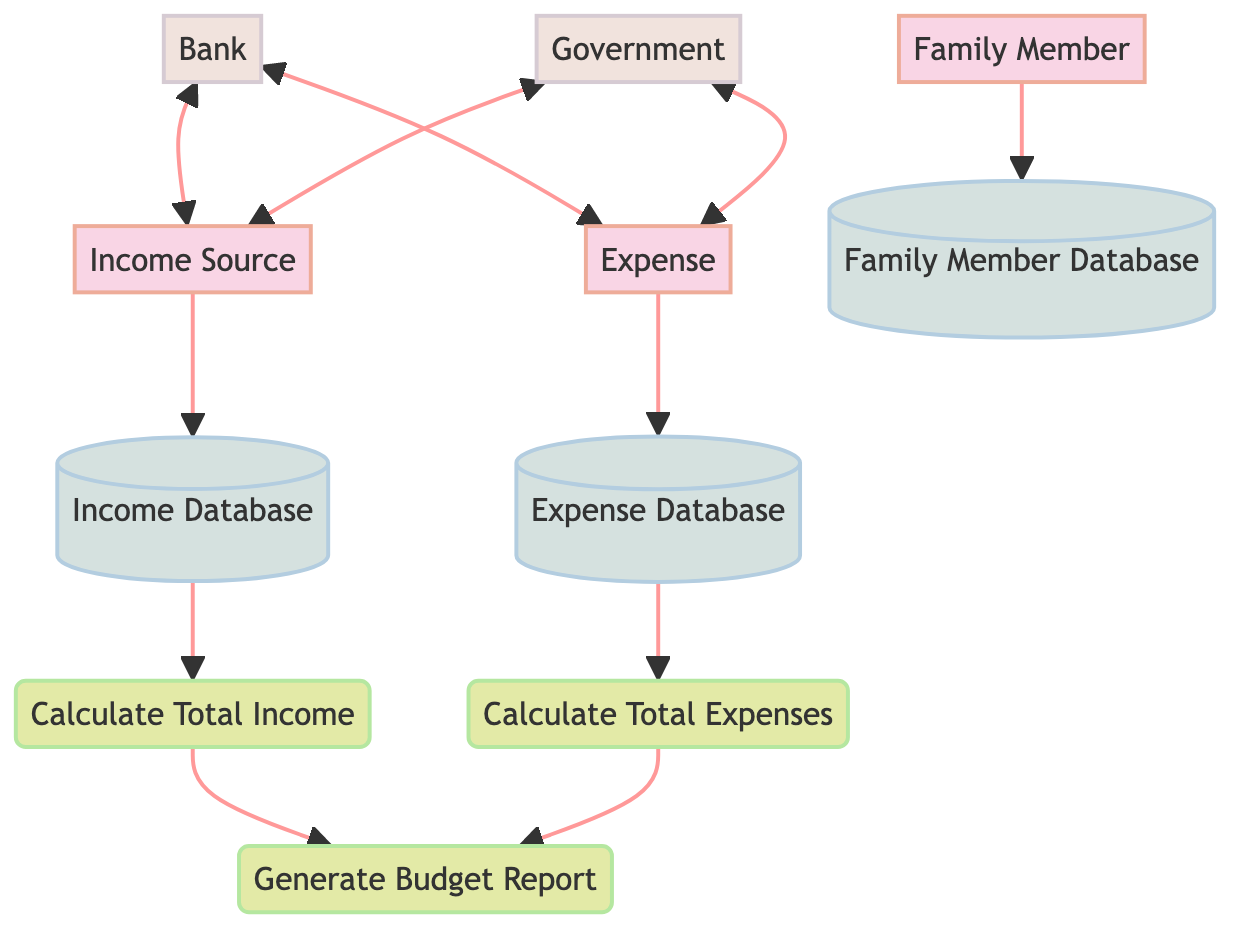What are the entities in the diagram? The diagram includes three entities: Family Member, Income Source, and Expense. Each has specific attributes associated with it, which define their characteristics.
Answer: Family Member, Income Source, Expense How many processes are in the diagram? The diagram contains three processes: Calculate Total Income, Calculate Total Expenses, and Generate Budget Report. Each process performs a specific function related to the family's budget.
Answer: 3 What is the output of the Calculate Total Income process? The process of Calculate Total Income takes Income Source as input and produces Total Income as output, which represents the sum of all income sources.
Answer: Total Income What is the purpose of the Expense Database? The Expense Database stores details regarding family expenditures, including Expense Type, Amount, and Due Date. It acts as a repository for tracking expenses systematically.
Answer: Stores details of all expenses Which external entity is involved in income and expenses? Both the Bank and Government are connected to Income Source and Expense, indicating their roles in managing financial aspects related to income and expenditure.
Answer: Bank and Government What inputs are required by the Generate Budget Report process? The Generate Budget Report process requires two inputs: Total Income and Total Expenses. It uses these figures to create a comprehensive budget report.
Answer: Total Income, Total Expenses How do Family Members interact with the Family Member Database? Family Members are connected to the Family Member Database, which stores their information, thus allowing for contributions or benefits from the budget planning process.
Answer: Direct interaction storing information What kind of relationship exists between the Bank and Expense? The relationship between the Bank and Expense is bidirectional, indicating that the Bank is involved in managing financial resources for expenditures.
Answer: Bidirectional relationship What information does the Family Member Database contain? The Family Member Database contains information such as Name, Age, and Occupation of each family member, which helps in understanding the family structure.
Answer: Name, Age, Occupation What is the first step in the budget calculation process? The first step in the budget calculation process is calculating Total Income, which aggregates the family's income sources before proceeding to expenses.
Answer: Calculate Total Income 